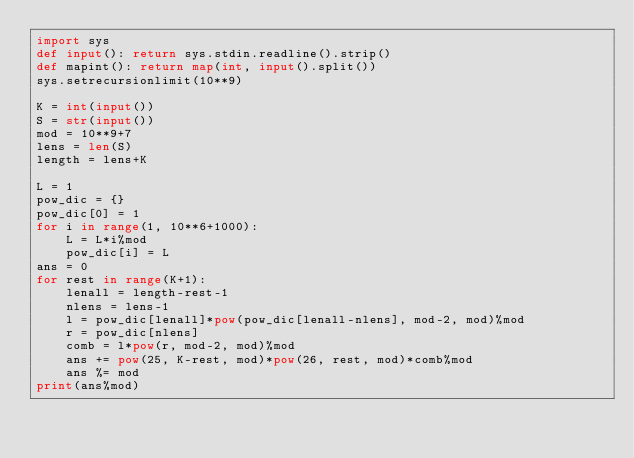Convert code to text. <code><loc_0><loc_0><loc_500><loc_500><_Python_>import sys
def input(): return sys.stdin.readline().strip()
def mapint(): return map(int, input().split())
sys.setrecursionlimit(10**9)

K = int(input())
S = str(input())
mod = 10**9+7
lens = len(S)
length = lens+K

L = 1
pow_dic = {}
pow_dic[0] = 1
for i in range(1, 10**6+1000):
    L = L*i%mod
    pow_dic[i] = L
ans = 0
for rest in range(K+1):
    lenall = length-rest-1
    nlens = lens-1
    l = pow_dic[lenall]*pow(pow_dic[lenall-nlens], mod-2, mod)%mod
    r = pow_dic[nlens]
    comb = l*pow(r, mod-2, mod)%mod
    ans += pow(25, K-rest, mod)*pow(26, rest, mod)*comb%mod
    ans %= mod
print(ans%mod)</code> 